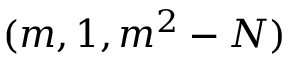Convert formula to latex. <formula><loc_0><loc_0><loc_500><loc_500>( m , 1 , m ^ { 2 } - N )</formula> 